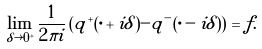<formula> <loc_0><loc_0><loc_500><loc_500>\lim _ { \delta \rightarrow 0 ^ { + } } \frac { 1 } { 2 \pi i } \left ( q ^ { + } ( \cdot + i \delta ) - q ^ { - } ( \cdot - i \delta ) \right ) = f .</formula> 